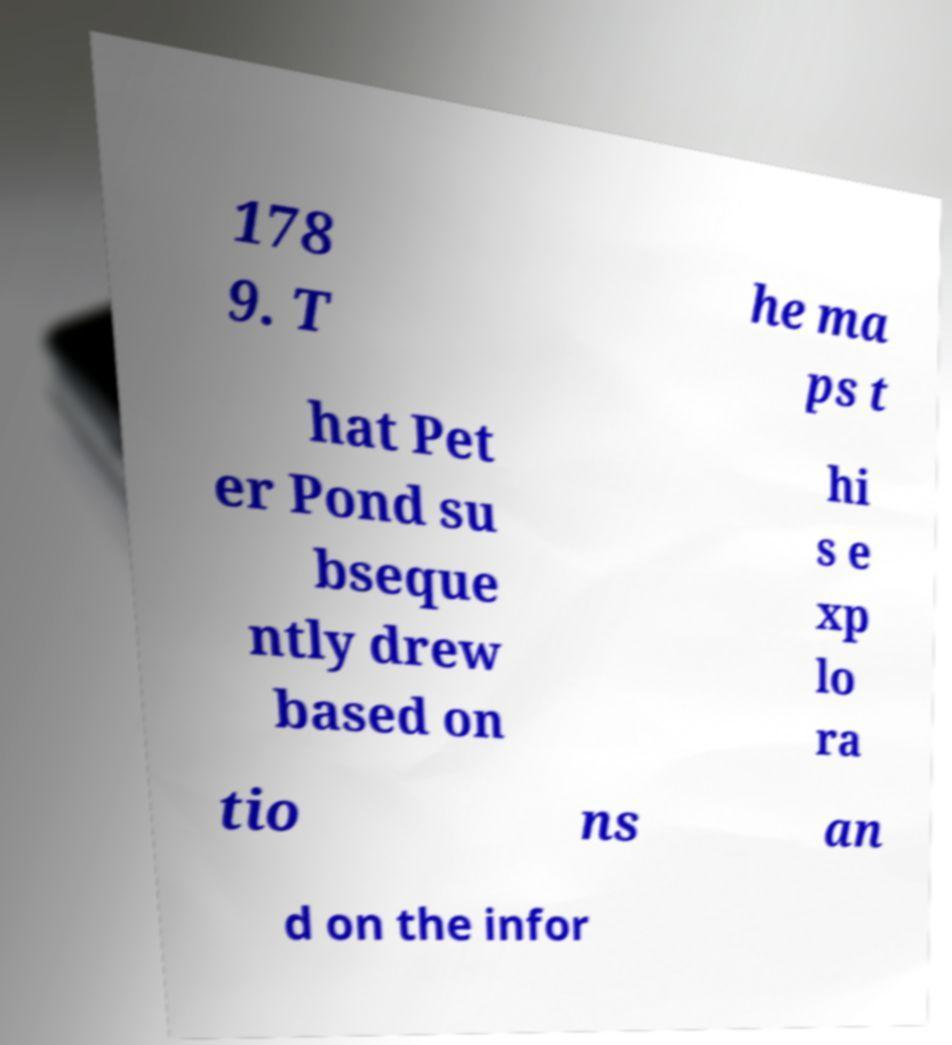Please identify and transcribe the text found in this image. 178 9. T he ma ps t hat Pet er Pond su bseque ntly drew based on hi s e xp lo ra tio ns an d on the infor 